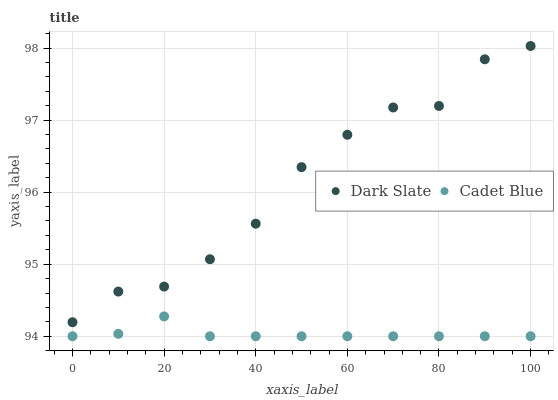Does Cadet Blue have the minimum area under the curve?
Answer yes or no. Yes. Does Dark Slate have the maximum area under the curve?
Answer yes or no. Yes. Does Cadet Blue have the maximum area under the curve?
Answer yes or no. No. Is Cadet Blue the smoothest?
Answer yes or no. Yes. Is Dark Slate the roughest?
Answer yes or no. Yes. Is Cadet Blue the roughest?
Answer yes or no. No. Does Cadet Blue have the lowest value?
Answer yes or no. Yes. Does Dark Slate have the highest value?
Answer yes or no. Yes. Does Cadet Blue have the highest value?
Answer yes or no. No. Is Cadet Blue less than Dark Slate?
Answer yes or no. Yes. Is Dark Slate greater than Cadet Blue?
Answer yes or no. Yes. Does Cadet Blue intersect Dark Slate?
Answer yes or no. No. 